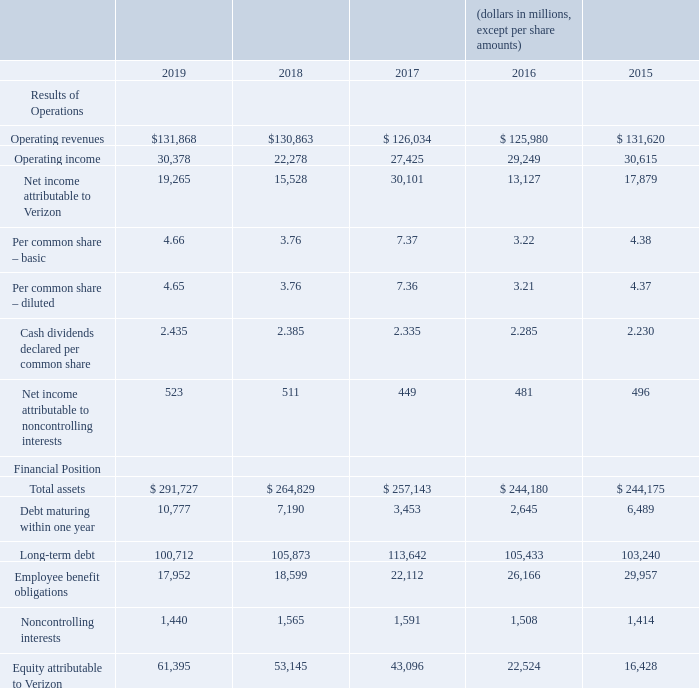Selected Financial Data
• Significant events affecting our historical earnings trends in 2018 through 2019 are described in “Special Items” in the “Management’s Discussion and Analysis of Financial Condition and Results of Operations” section.
• 2017 data includes severance, pension and benefit charges, gain on spectrum license transactions, acquisition and integration related charges, product realignment charges, net gain on sale of divested businesses and early debt redemption costs. 2016 data includes severance, pension and benefit charges, gain on spectrum license transactions, net gain on sale of divested businesses and early debt redemption costs. 2015 data includes severance, pension and benefit credits and gain on spectrum license transactions.
• On January 1, 2019, we adopted several Accounting Standards Updates (ASUs) that were issued by the Financial Accounting Standards Board (FASB) using the modified retrospective basis. On January 1, 2018, we adopted several ASUs that were issued by the FASB. These standards were adopted on different bases, including: (1) prospective; (2) full retrospective; and (3) modified retrospective.
Based on the method of adoption, certain figures are not comparable, with full retrospective reflected in all periods. See Note 1 to the consolidated financial statements for additional information.
What was the operating revenue in 2019?
Answer scale should be: million. $131,868. What was the Per common share – basic in 2019? 4.66. What was the Total assets in 2019?
Answer scale should be: million. $ 291,727. What was the change in operating revenues from 2017 to 2018?
Answer scale should be: million. 130,863 - 126,034
Answer: 4829. What was the average operating income for 2015-2019?
Answer scale should be: million. (30,378 + 22,278 + 27,425 + 29,249 + 30,615) / 5
Answer: 27989. What was the change in the Per common share – basic from 2018 to 2019? 4.66 - 3.76
Answer: 0.9. 